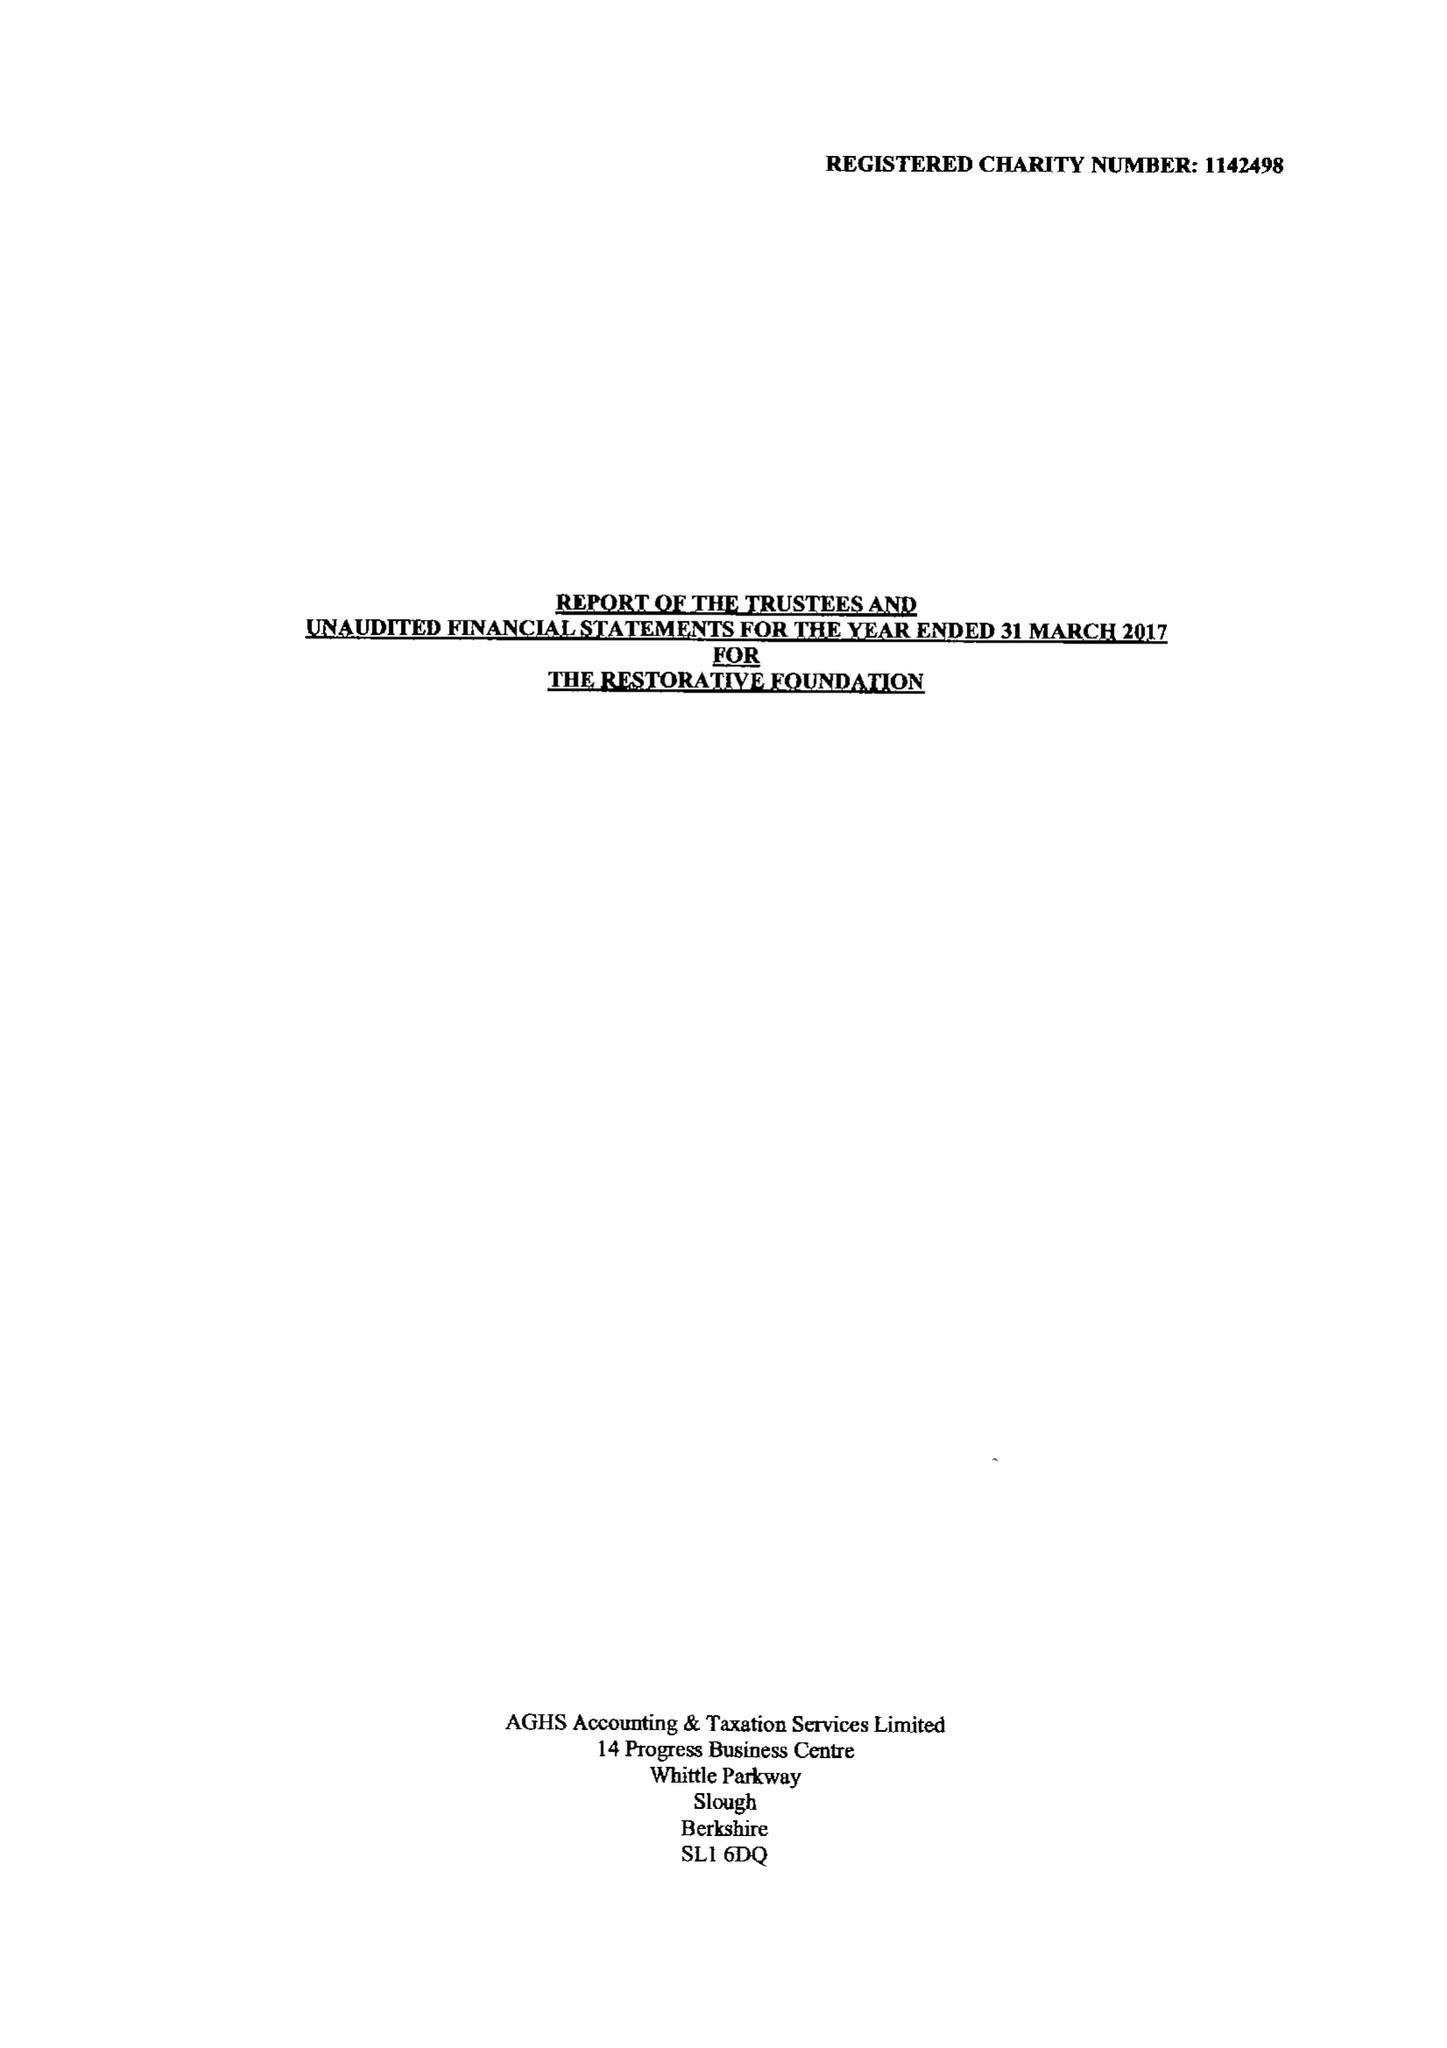What is the value for the charity_number?
Answer the question using a single word or phrase. 1142498 